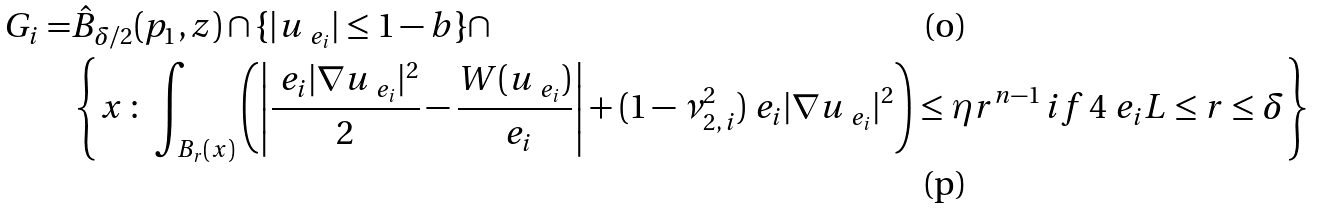<formula> <loc_0><loc_0><loc_500><loc_500>G _ { i } = & \hat { B } _ { \delta / 2 } ( { p } _ { 1 } , z ) \cap \{ | u _ { \ e _ { i } } | \leq 1 - b \} \cap \\ & \left \{ x \, \colon \, \int _ { B _ { r } ( x ) } \left ( \left | \frac { \ e _ { i } | \nabla u _ { \ e _ { i } } | ^ { 2 } } { 2 } - \frac { W ( u _ { \ e _ { i } } ) } { \ e _ { i } } \right | + ( 1 - \nu _ { 2 , \, i } ^ { 2 } ) \ e _ { i } | \nabla u _ { \ e _ { i } } | ^ { 2 } \right ) \leq \eta r ^ { n - 1 } \, i f \, 4 \ e _ { i } L \leq r \leq \delta \right \}</formula> 